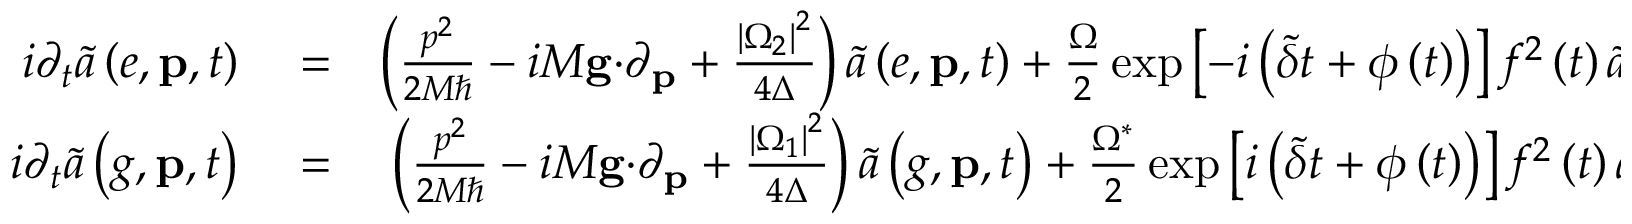<formula> <loc_0><loc_0><loc_500><loc_500>\begin{array} { r l r } { i \partial _ { t } \tilde { a } \left ( e , p , t \right ) } & = } & { \left ( \frac { p ^ { 2 } } { 2 M } - i M g \cdot \partial _ { p } + \frac { \left | \Omega _ { 2 } \right | ^ { 2 } } { 4 \Delta } \right ) \tilde { a } \left ( e , p , t \right ) + \frac { \Omega } { 2 } \exp \left [ - i \left ( \tilde { \delta } t + \phi \left ( t \right ) \right ) \right ] f ^ { 2 } \left ( t \right ) \tilde { a } \left ( g , p - \hbar { k } , t \right ) , } \\ { i \partial _ { t } \tilde { a } \left ( g , p , t \right ) } & = } & { \left ( \frac { p ^ { 2 } } { 2 M } - i M g \cdot \partial _ { p } + \frac { \left | \Omega _ { 1 } \right | ^ { 2 } } { 4 \Delta } \right ) \tilde { a } \left ( g , p , t \right ) + \frac { \Omega ^ { \ast } } { 2 } \exp \left [ i \left ( \tilde { \delta } t + \phi \left ( t \right ) \right ) \right ] f ^ { 2 } \left ( t \right ) \tilde { a } \left ( e , p + \hbar { k } , t \right ) , } \end{array}</formula> 